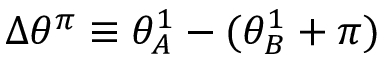Convert formula to latex. <formula><loc_0><loc_0><loc_500><loc_500>\Delta \theta ^ { \pi } \equiv \theta _ { A } ^ { 1 } - ( \theta _ { B } ^ { 1 } + \pi )</formula> 